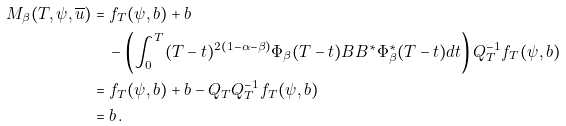Convert formula to latex. <formula><loc_0><loc_0><loc_500><loc_500>M _ { \beta } ( T , \psi , \overline { u } ) & = f _ { T } ( \psi , b ) + b \\ & \quad - \left ( \int _ { 0 } ^ { T } ( T - t ) ^ { 2 ( 1 - \alpha - \beta ) } \Phi _ { \beta } ( T - t ) B B ^ { * } \Phi _ { \beta } ^ { * } ( T - t ) d t \right ) Q _ { T } ^ { - 1 } f _ { T } ( \psi , b ) \\ & = f _ { T } ( \psi , b ) + b - Q _ { T } Q _ { T } ^ { - 1 } f _ { T } ( \psi , b ) \\ & = b \, .</formula> 